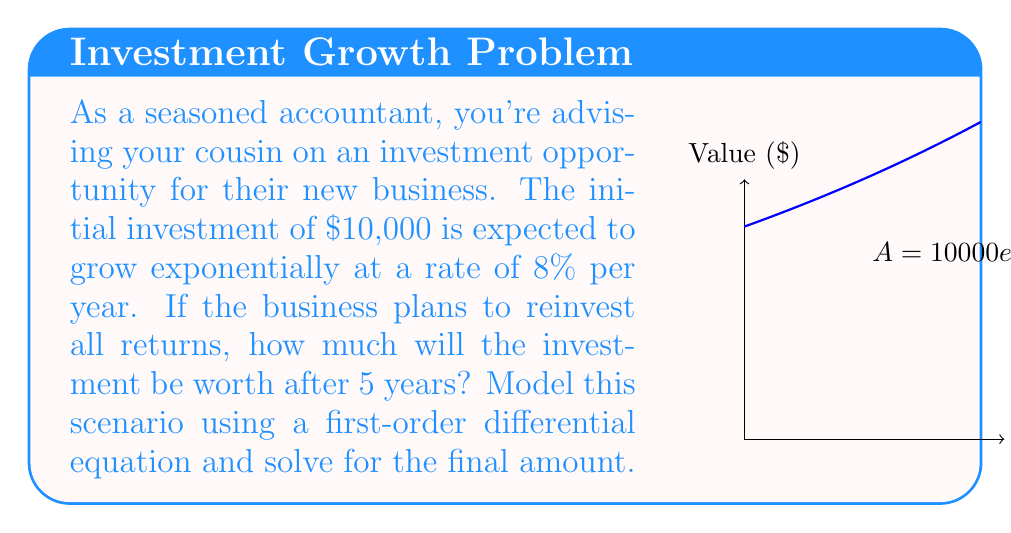What is the answer to this math problem? Let's approach this step-by-step:

1) Let $A(t)$ be the amount of money at time $t$ (in years). We know that the rate of change of $A$ with respect to $t$ is proportional to $A$ itself. This gives us the differential equation:

   $$\frac{dA}{dt} = kA$$

   where $k$ is the growth rate constant.

2) We're given that the growth rate is 8% per year, so $k = 0.08$.

3) The initial condition is $A(0) = 10000$.

4) The general solution to this differential equation is:

   $$A(t) = Ce^{kt}$$

   where $C$ is a constant we need to determine.

5) Using the initial condition:

   $$10000 = Ce^{0.08 \cdot 0} = C$$

6) Therefore, our specific solution is:

   $$A(t) = 10000e^{0.08t}$$

7) To find the amount after 5 years, we evaluate $A(5)$:

   $$A(5) = 10000e^{0.08 \cdot 5} = 10000e^{0.4}$$

8) Using a calculator or computer:

   $$A(5) \approx 14918.25$$

Therefore, after 5 years, the investment will be worth approximately $14,918.25.
Answer: $14,918.25 